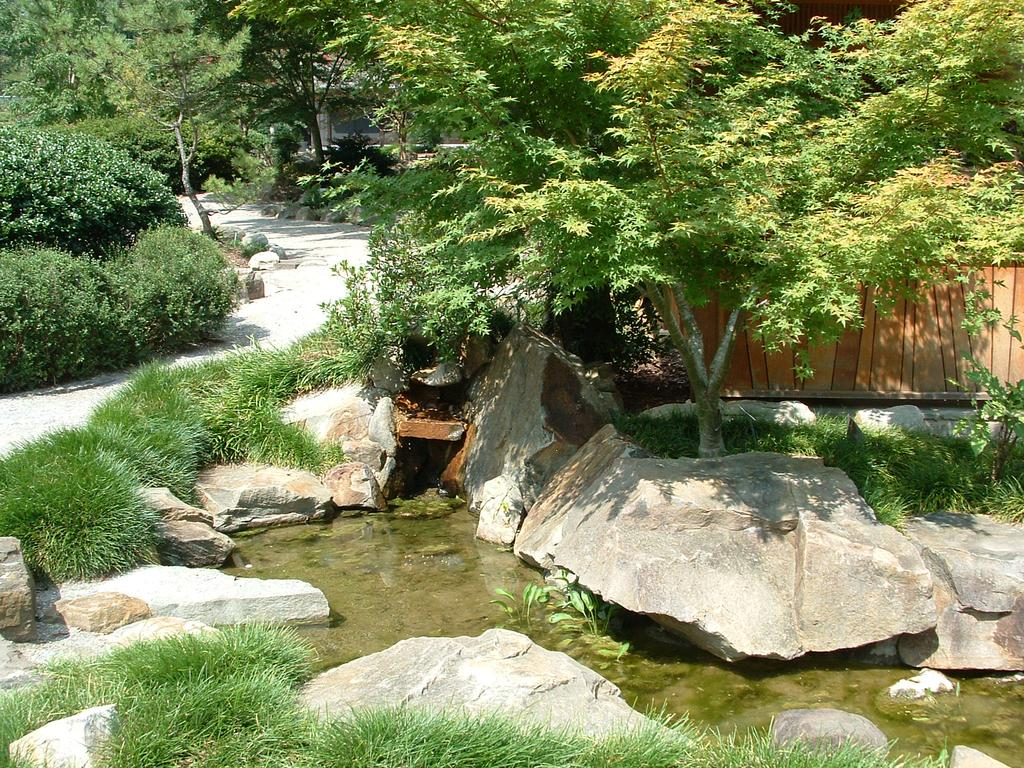What type of natural body of water is visible in the image? There is a lake in the image. What can be found in or around the lake? There are stones and trees visible in the image. What type of vegetation is present at the bottom of the image? There is grass at the bottom of the image. What type of pathway is visible at the top of the image? There is a lane at the top of the image. What type of leaf is being used to settle an argument in the image? There is no leaf or argument present in the image. What color is the sock that is visible in the image? There is no sock present in the image. 